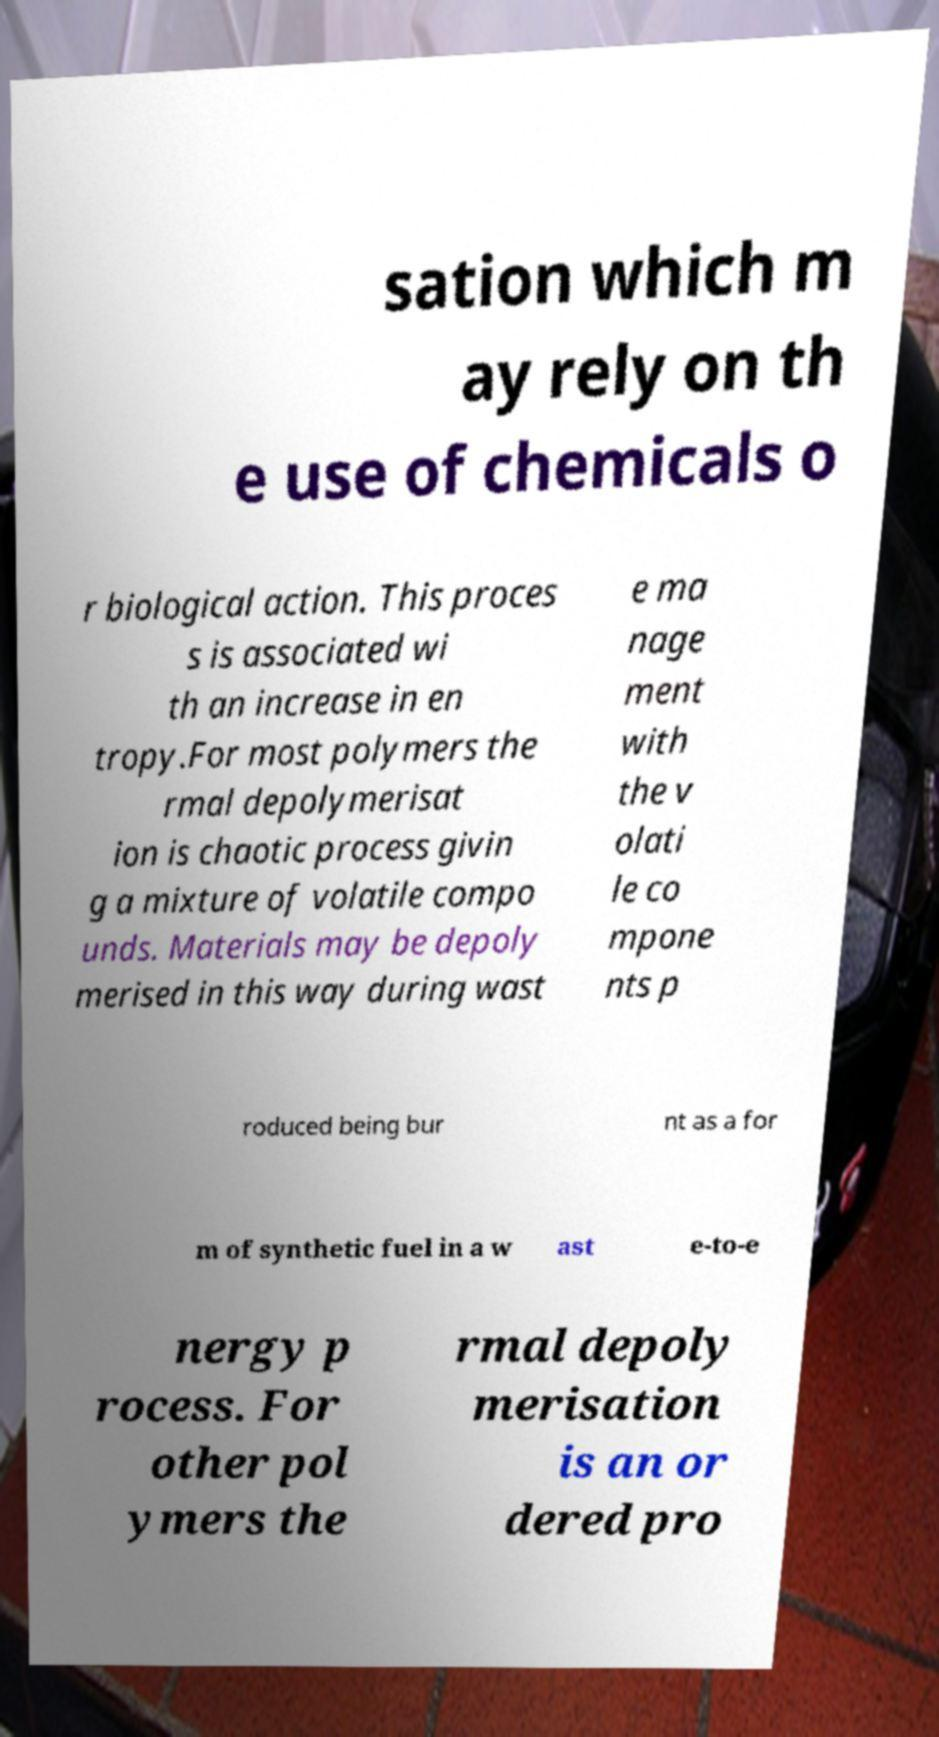Can you read and provide the text displayed in the image?This photo seems to have some interesting text. Can you extract and type it out for me? sation which m ay rely on th e use of chemicals o r biological action. This proces s is associated wi th an increase in en tropy.For most polymers the rmal depolymerisat ion is chaotic process givin g a mixture of volatile compo unds. Materials may be depoly merised in this way during wast e ma nage ment with the v olati le co mpone nts p roduced being bur nt as a for m of synthetic fuel in a w ast e-to-e nergy p rocess. For other pol ymers the rmal depoly merisation is an or dered pro 